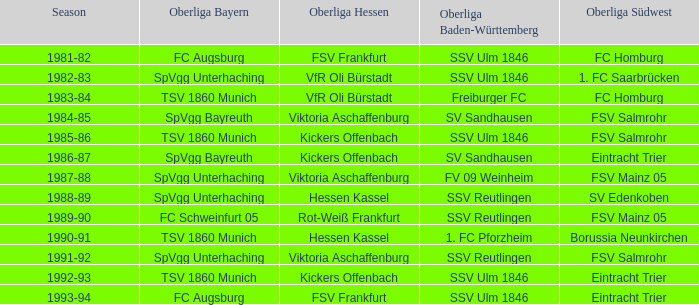Which oberliga südwes has an oberliga baden-württemberg of sv sandhausen in 1984-85? FSV Salmrohr. 